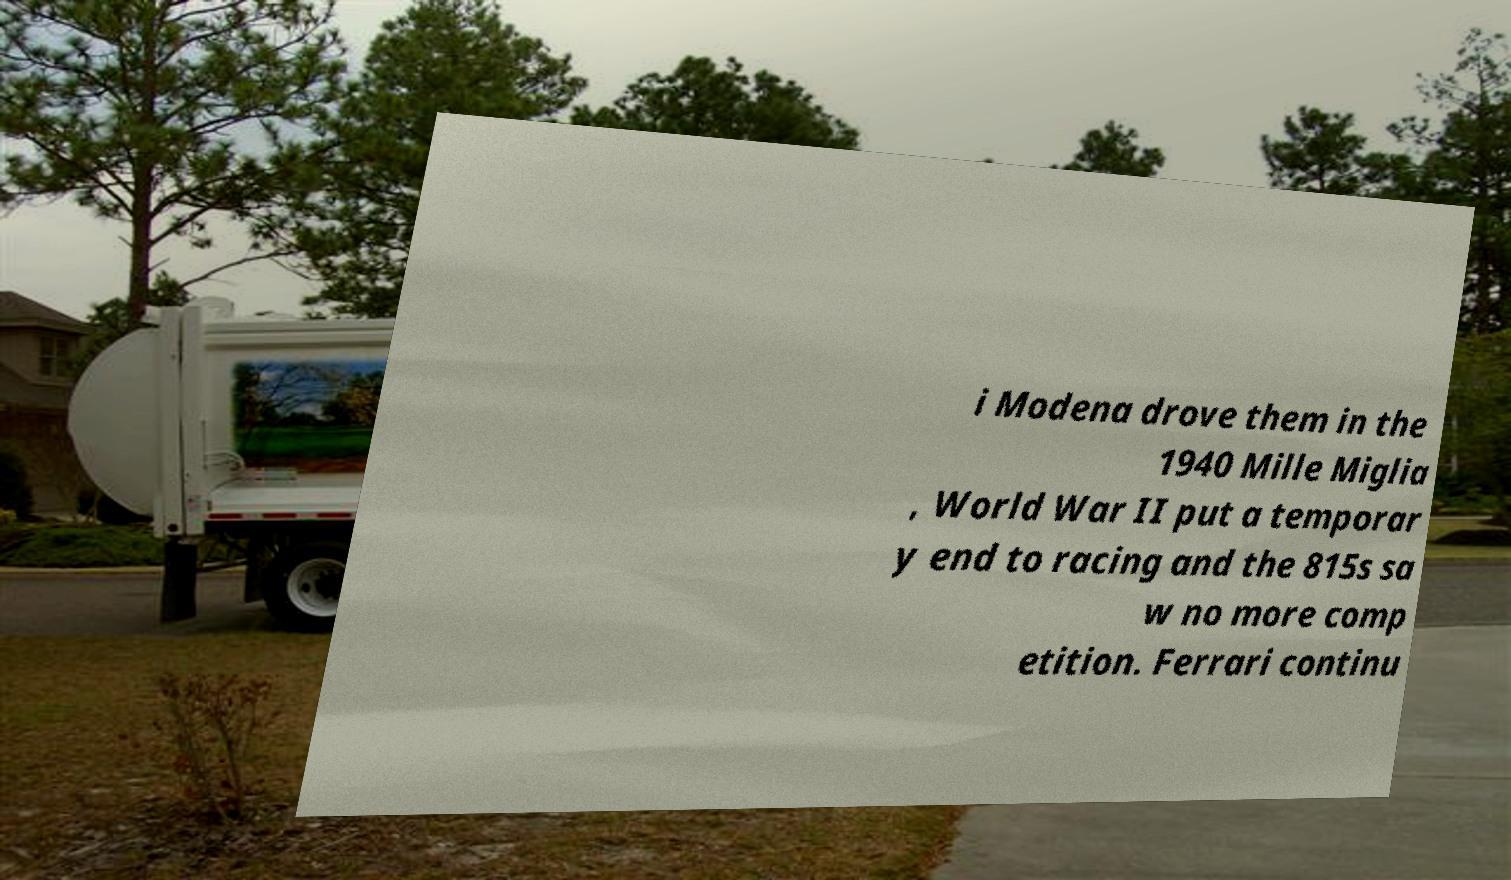Could you extract and type out the text from this image? i Modena drove them in the 1940 Mille Miglia , World War II put a temporar y end to racing and the 815s sa w no more comp etition. Ferrari continu 